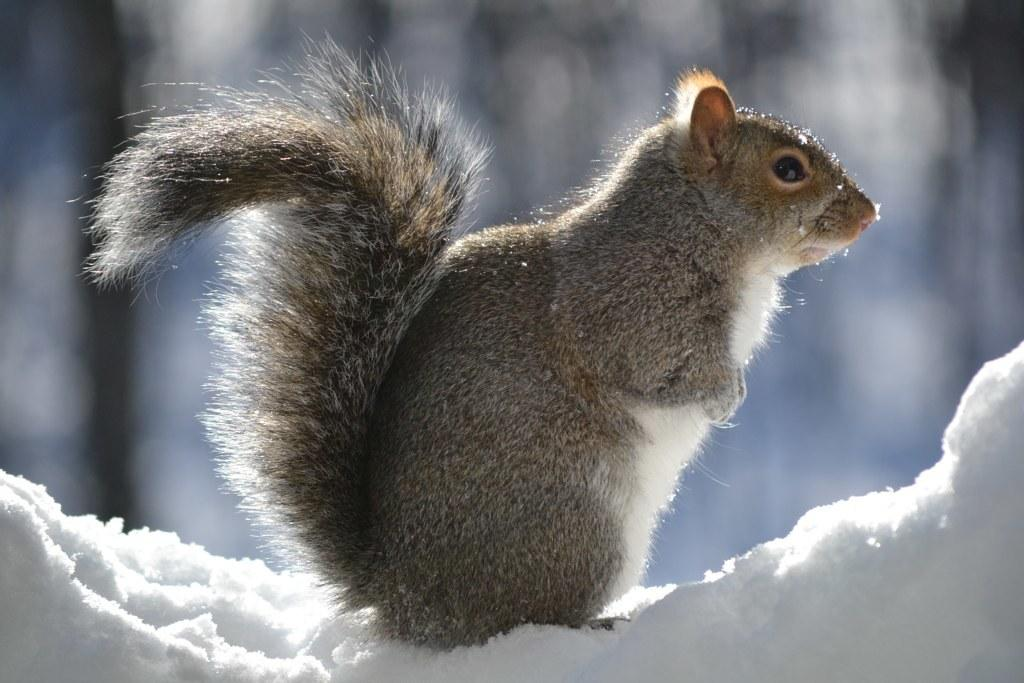What type of animal is in the image? There is a squirrel in the image. What is the squirrel standing on in the image? The squirrel is on the snow. What type of balls can be seen in the image? There are no balls present in the image; it features a squirrel on the snow. What kind of cracker is the squirrel eating in the image? There is no cracker present in the image; the squirrel is simply standing on the snow. 